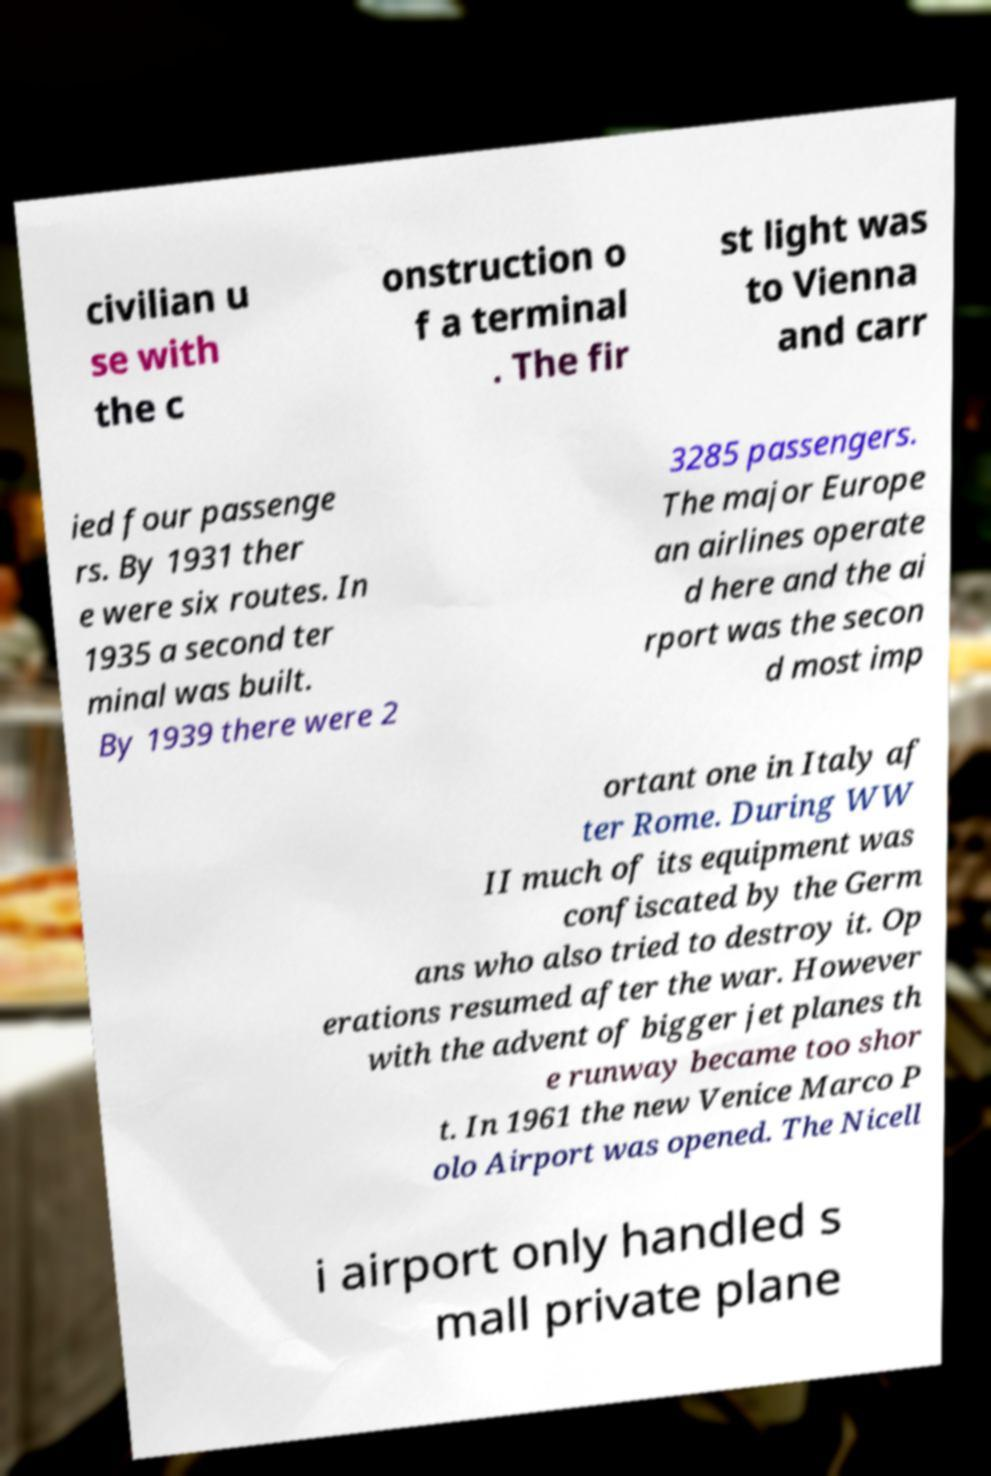What messages or text are displayed in this image? I need them in a readable, typed format. civilian u se with the c onstruction o f a terminal . The fir st light was to Vienna and carr ied four passenge rs. By 1931 ther e were six routes. In 1935 a second ter minal was built. By 1939 there were 2 3285 passengers. The major Europe an airlines operate d here and the ai rport was the secon d most imp ortant one in Italy af ter Rome. During WW II much of its equipment was confiscated by the Germ ans who also tried to destroy it. Op erations resumed after the war. However with the advent of bigger jet planes th e runway became too shor t. In 1961 the new Venice Marco P olo Airport was opened. The Nicell i airport only handled s mall private plane 